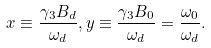<formula> <loc_0><loc_0><loc_500><loc_500>x & \equiv \frac { \gamma _ { 3 } B _ { d } } { \omega _ { d } } , y \equiv \frac { \gamma _ { 3 } B _ { 0 } } { \omega _ { d } } = \frac { \omega _ { 0 } } { \omega _ { d } } .</formula> 